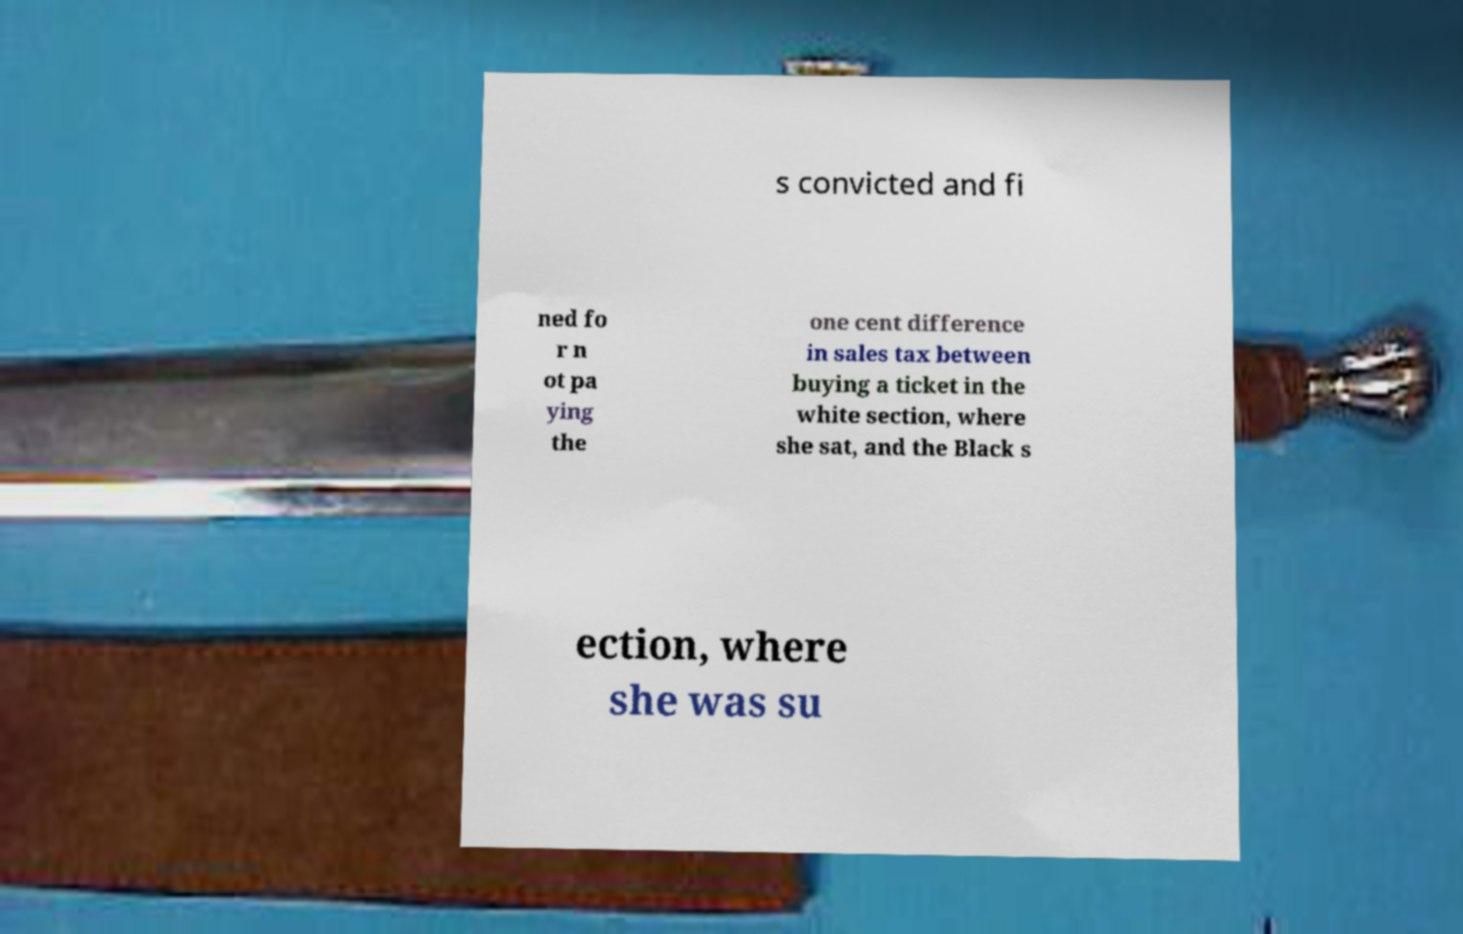For documentation purposes, I need the text within this image transcribed. Could you provide that? s convicted and fi ned fo r n ot pa ying the one cent difference in sales tax between buying a ticket in the white section, where she sat, and the Black s ection, where she was su 